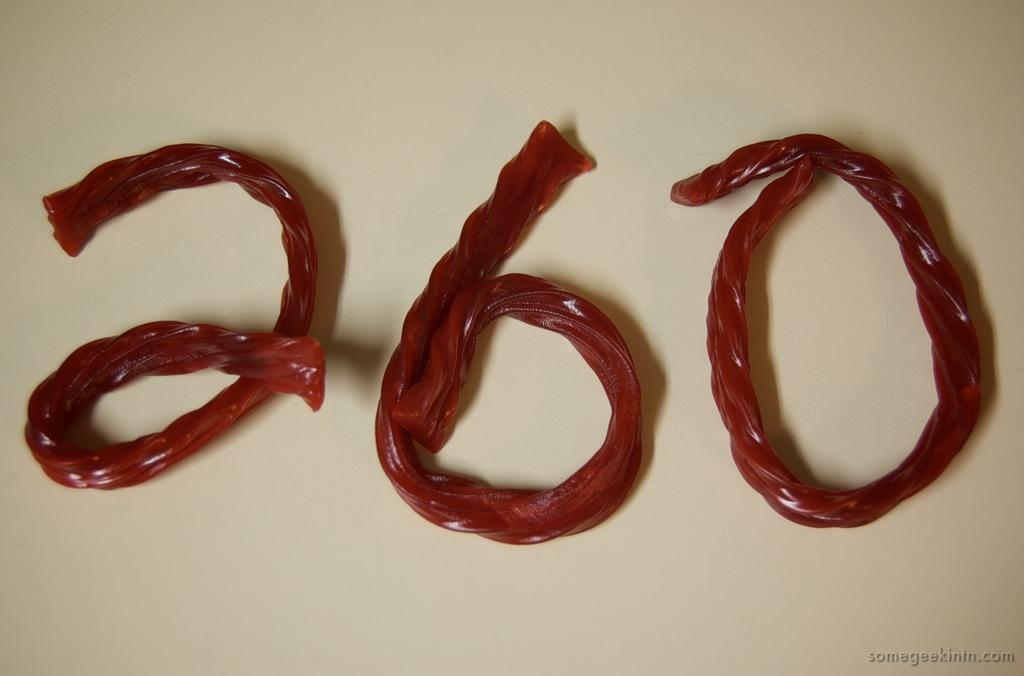What is the main subject of the image? There is a food item in the image. Can you describe the surface on which the food item is placed? The food item is placed on a white surface. Is there any additional information or markings in the image? Yes, there is a watermark in the bottom right corner of the image. How many snakes are slithering around the food item in the image? There are no snakes present in the image; it only features a food item placed on a white surface. What type of plough is being used to prepare the food item in the image? There is no plough present in the image, as it only features a food item placed on a white surface. 